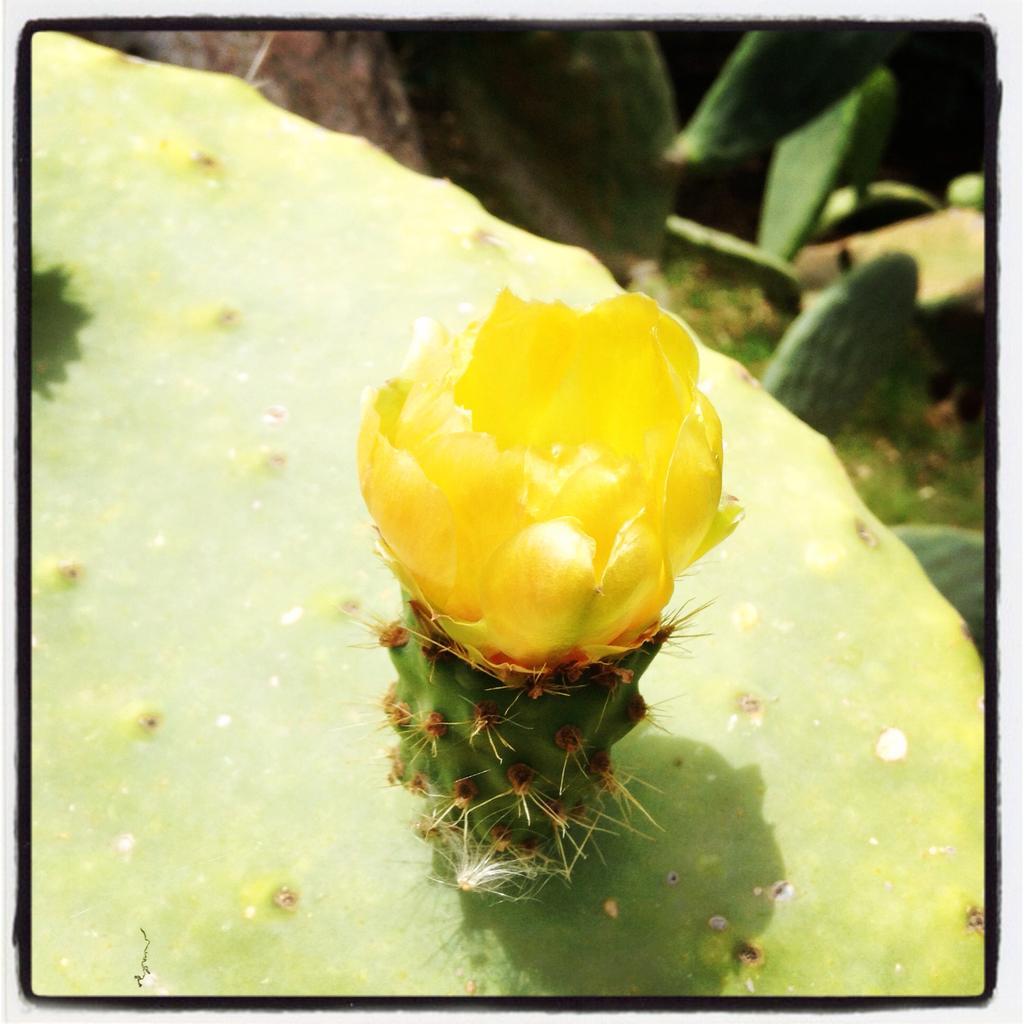Could you give a brief overview of what you see in this image? There is a cactus plant with a yellow flower. In the background there are many cactus plants. 